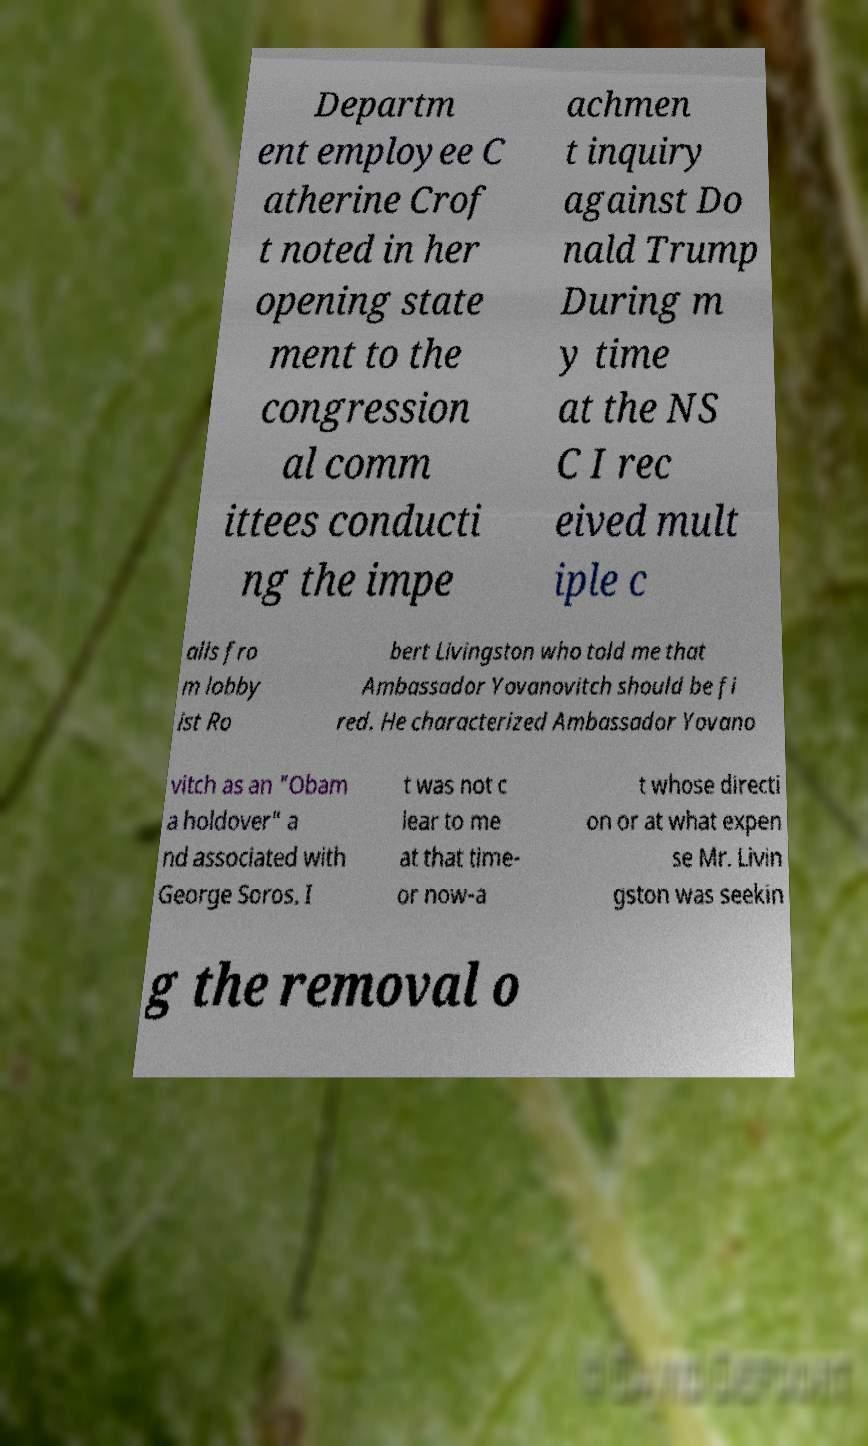Please identify and transcribe the text found in this image. Departm ent employee C atherine Crof t noted in her opening state ment to the congression al comm ittees conducti ng the impe achmen t inquiry against Do nald Trump During m y time at the NS C I rec eived mult iple c alls fro m lobby ist Ro bert Livingston who told me that Ambassador Yovanovitch should be fi red. He characterized Ambassador Yovano vitch as an "Obam a holdover" a nd associated with George Soros. I t was not c lear to me at that time- or now-a t whose directi on or at what expen se Mr. Livin gston was seekin g the removal o 